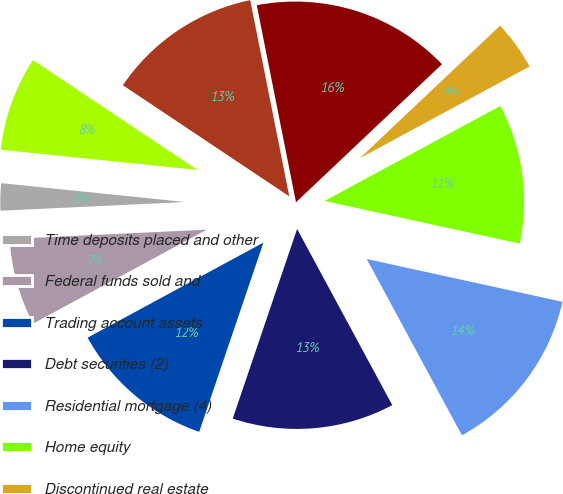Convert chart to OTSL. <chart><loc_0><loc_0><loc_500><loc_500><pie_chart><fcel>Time deposits placed and other<fcel>Federal funds sold and<fcel>Trading account assets<fcel>Debt securities (2)<fcel>Residential mortgage (4)<fcel>Home equity<fcel>Discontinued real estate<fcel>Total consumer<fcel>US commercial<fcel>Commercial real estate (7)<nl><fcel>2.38%<fcel>7.14%<fcel>11.9%<fcel>13.09%<fcel>13.69%<fcel>11.31%<fcel>4.17%<fcel>16.07%<fcel>12.5%<fcel>7.74%<nl></chart> 